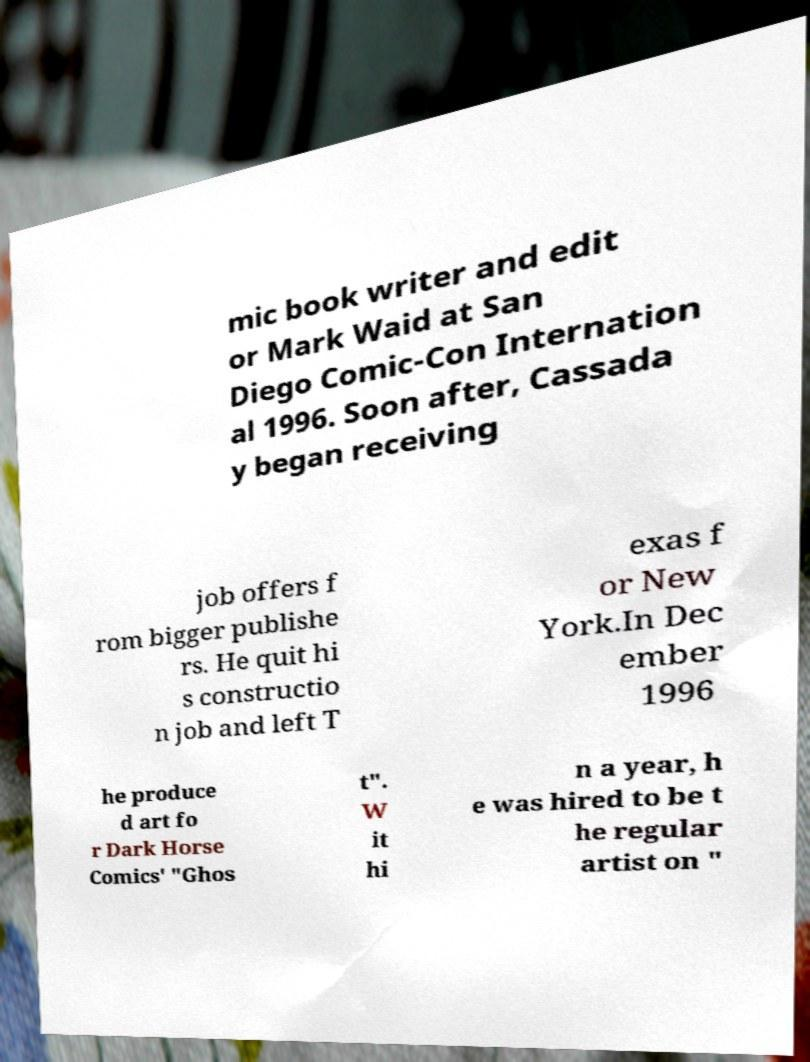Can you read and provide the text displayed in the image?This photo seems to have some interesting text. Can you extract and type it out for me? mic book writer and edit or Mark Waid at San Diego Comic-Con Internation al 1996. Soon after, Cassada y began receiving job offers f rom bigger publishe rs. He quit hi s constructio n job and left T exas f or New York.In Dec ember 1996 he produce d art fo r Dark Horse Comics' "Ghos t". W it hi n a year, h e was hired to be t he regular artist on " 